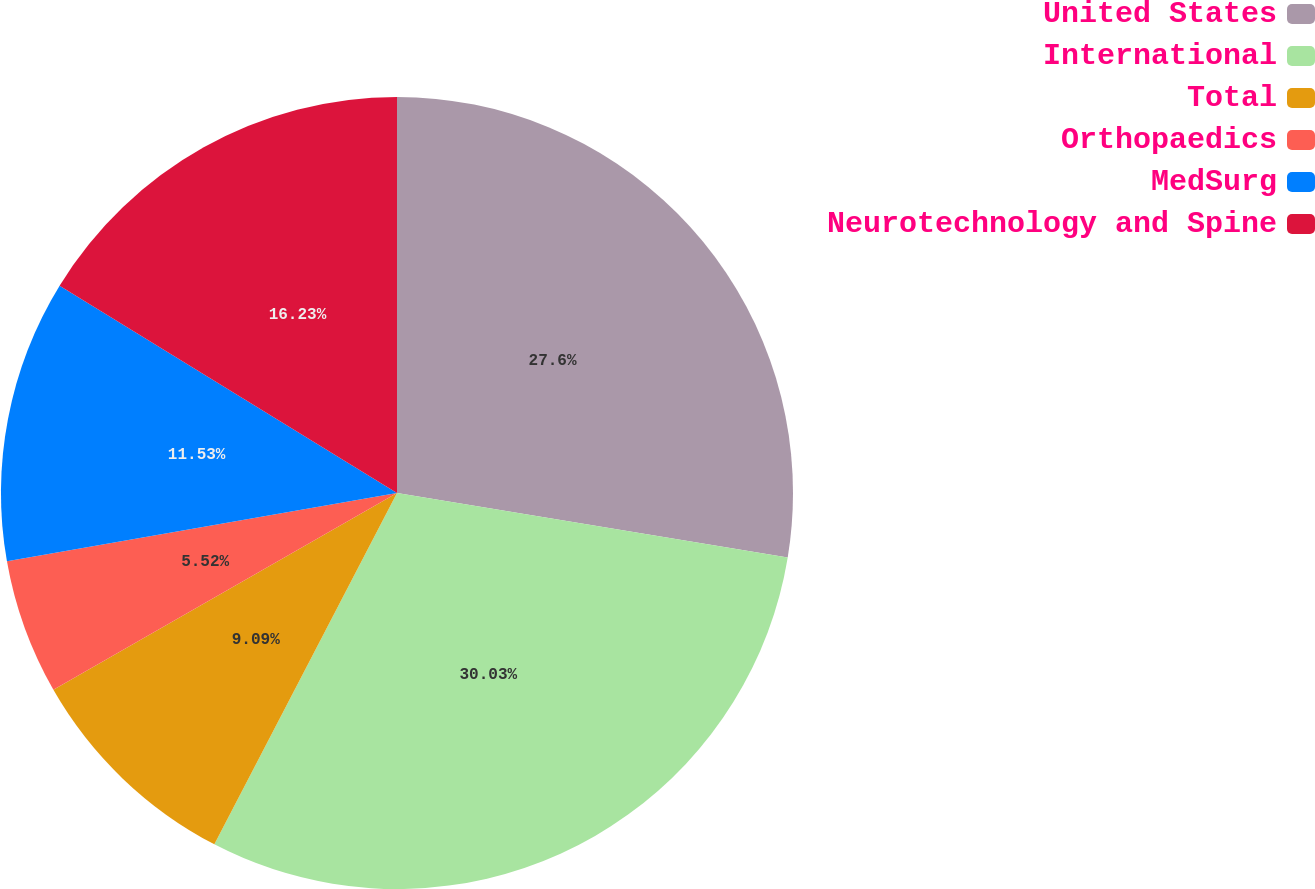<chart> <loc_0><loc_0><loc_500><loc_500><pie_chart><fcel>United States<fcel>International<fcel>Total<fcel>Orthopaedics<fcel>MedSurg<fcel>Neurotechnology and Spine<nl><fcel>27.6%<fcel>30.03%<fcel>9.09%<fcel>5.52%<fcel>11.53%<fcel>16.23%<nl></chart> 